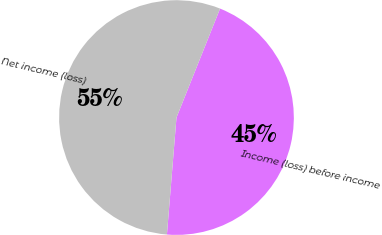<chart> <loc_0><loc_0><loc_500><loc_500><pie_chart><fcel>Income (loss) before income<fcel>Net income (loss)<nl><fcel>45.24%<fcel>54.76%<nl></chart> 